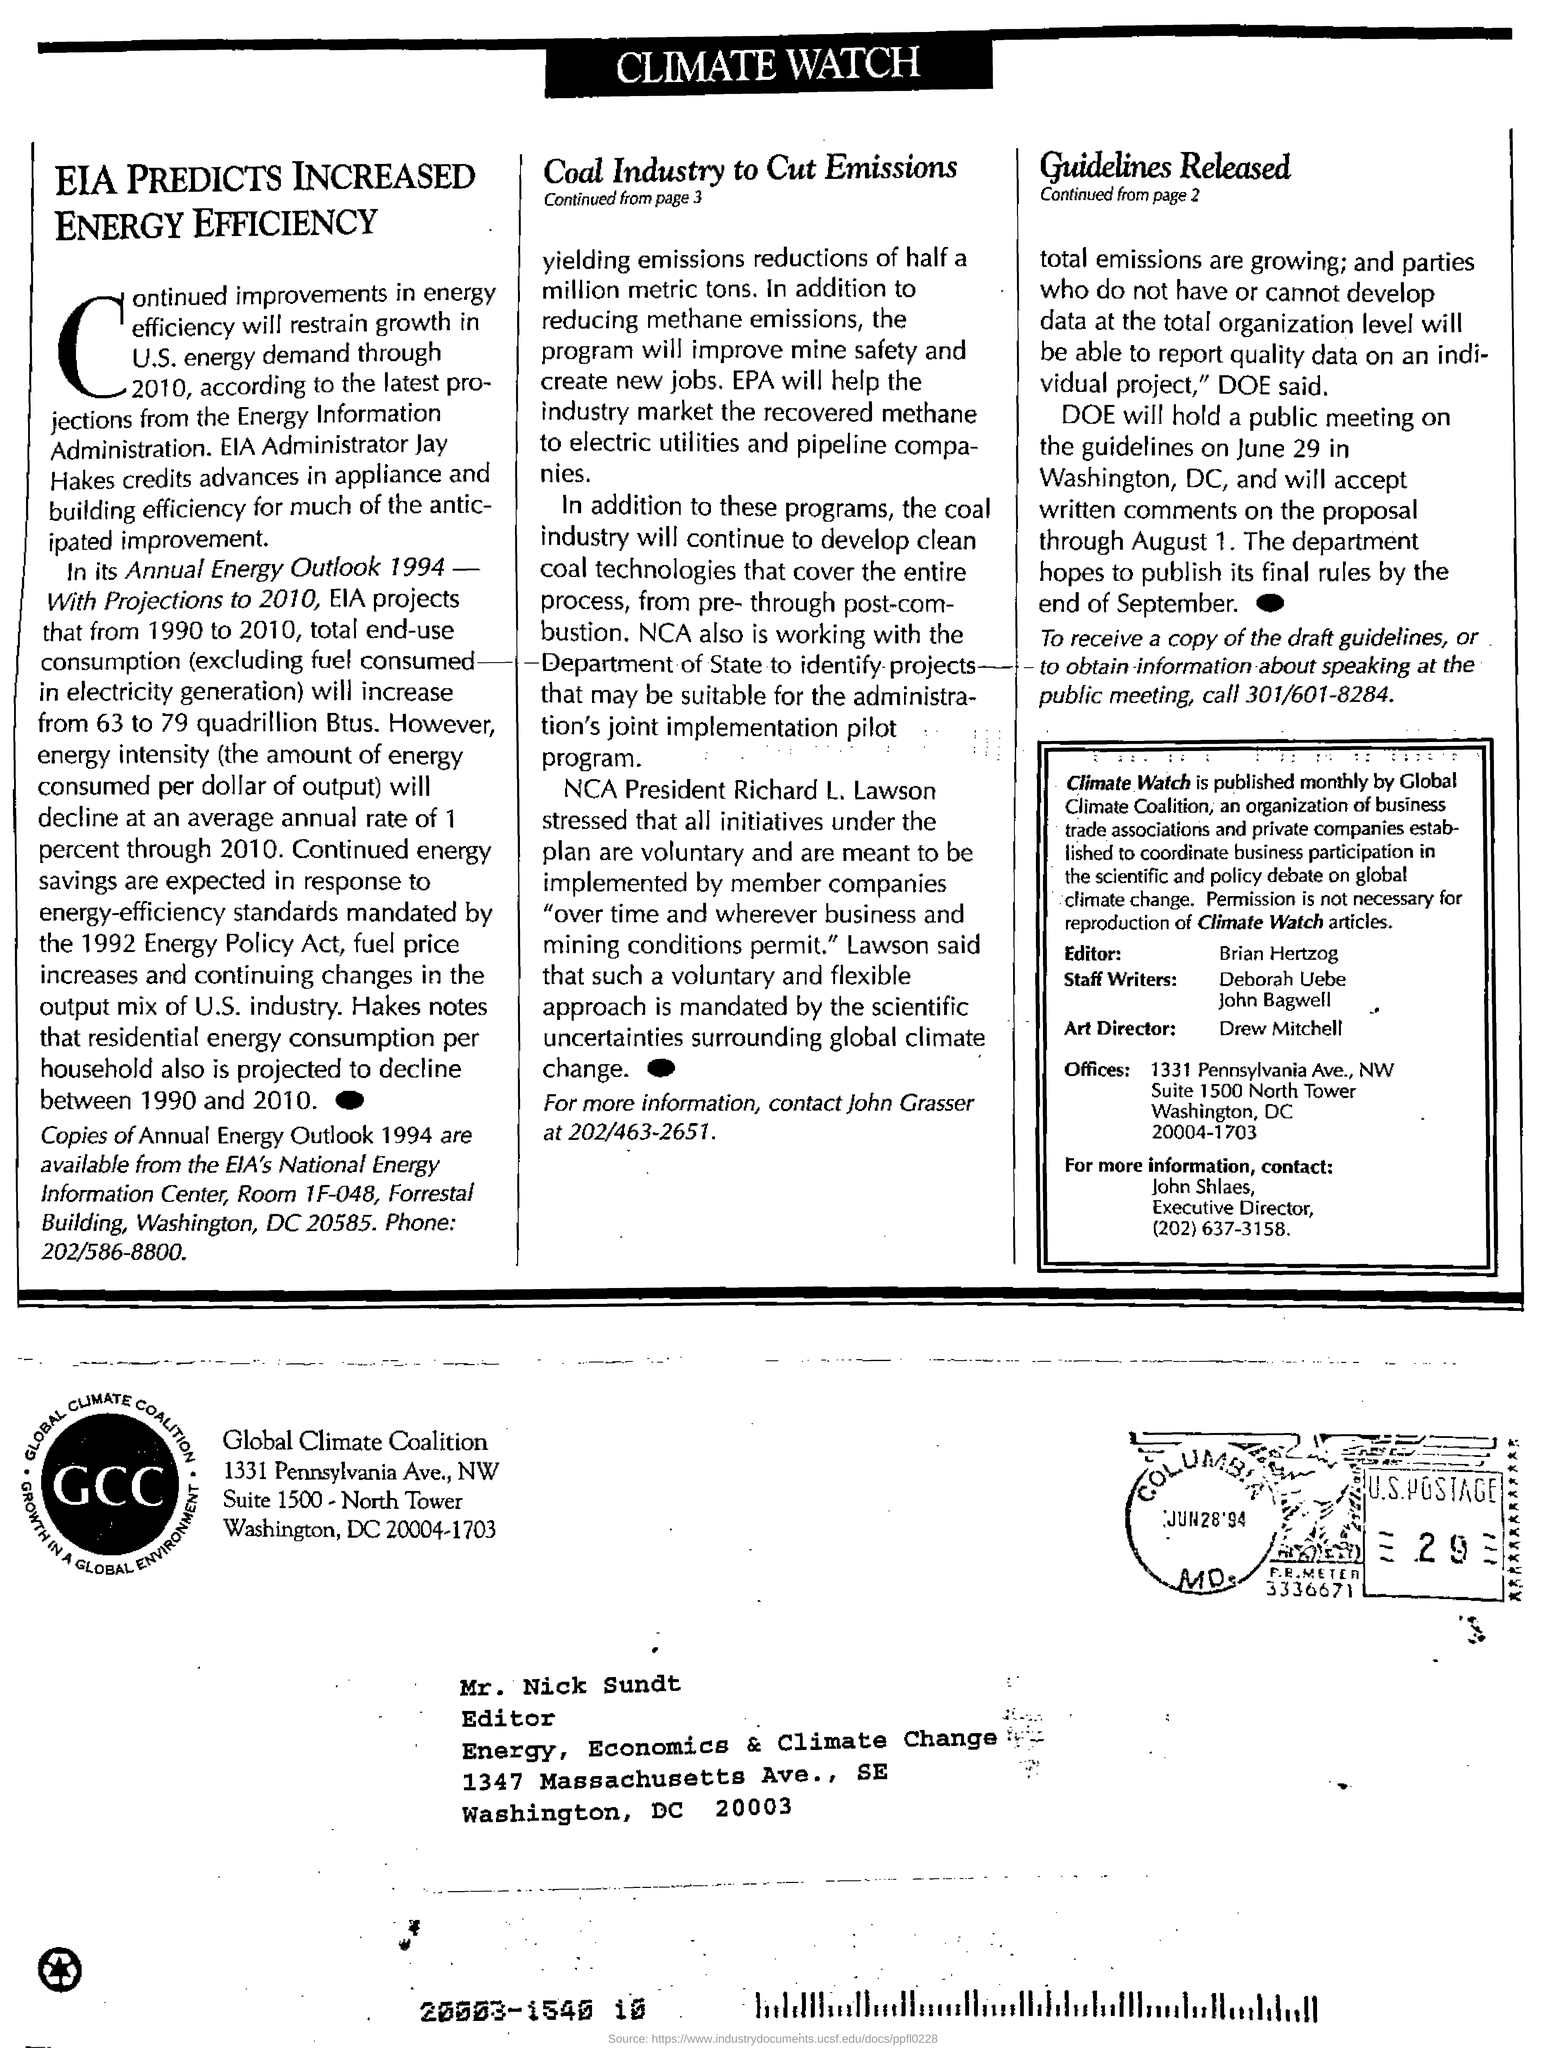To whom is the letter sent?
Ensure brevity in your answer.  Mr. Nick Sundt. Who publishes Climate watch?
Your answer should be compact. Global climate coalition. What is global climate coalition?
Keep it short and to the point. An organization of business trade associations and private companies established to coordinate business participation in the scientific and policy debate on global climate change. Who is the editor of climate watch?
Your answer should be compact. Brian hertzog. Who is NCA president?
Keep it short and to the point. Richard L. Lawson. Who is the NCA president?
Ensure brevity in your answer.  Richard L. Lawson. Who is the art director?
Keep it short and to the point. Drew mitchell. 